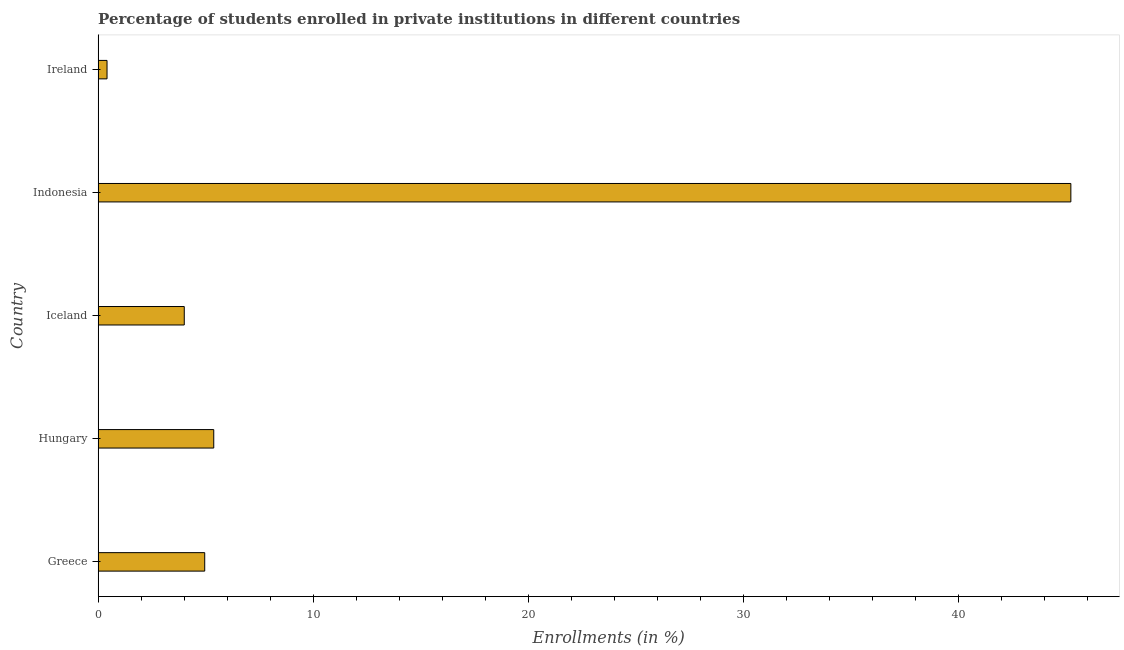Does the graph contain any zero values?
Your answer should be very brief. No. What is the title of the graph?
Provide a short and direct response. Percentage of students enrolled in private institutions in different countries. What is the label or title of the X-axis?
Your answer should be compact. Enrollments (in %). What is the label or title of the Y-axis?
Provide a short and direct response. Country. What is the enrollments in private institutions in Indonesia?
Ensure brevity in your answer.  45.2. Across all countries, what is the maximum enrollments in private institutions?
Give a very brief answer. 45.2. Across all countries, what is the minimum enrollments in private institutions?
Your response must be concise. 0.41. In which country was the enrollments in private institutions minimum?
Your response must be concise. Ireland. What is the sum of the enrollments in private institutions?
Give a very brief answer. 59.95. What is the difference between the enrollments in private institutions in Hungary and Iceland?
Your response must be concise. 1.37. What is the average enrollments in private institutions per country?
Keep it short and to the point. 11.99. What is the median enrollments in private institutions?
Keep it short and to the point. 4.95. In how many countries, is the enrollments in private institutions greater than 40 %?
Give a very brief answer. 1. What is the ratio of the enrollments in private institutions in Indonesia to that in Ireland?
Ensure brevity in your answer.  109.08. What is the difference between the highest and the second highest enrollments in private institutions?
Provide a succinct answer. 39.83. What is the difference between the highest and the lowest enrollments in private institutions?
Provide a short and direct response. 44.79. Are all the bars in the graph horizontal?
Your response must be concise. Yes. How many countries are there in the graph?
Provide a succinct answer. 5. What is the Enrollments (in %) in Greece?
Keep it short and to the point. 4.95. What is the Enrollments (in %) in Hungary?
Offer a very short reply. 5.37. What is the Enrollments (in %) in Iceland?
Offer a terse response. 4. What is the Enrollments (in %) in Indonesia?
Make the answer very short. 45.2. What is the Enrollments (in %) of Ireland?
Provide a short and direct response. 0.41. What is the difference between the Enrollments (in %) in Greece and Hungary?
Give a very brief answer. -0.42. What is the difference between the Enrollments (in %) in Greece and Iceland?
Give a very brief answer. 0.95. What is the difference between the Enrollments (in %) in Greece and Indonesia?
Offer a very short reply. -40.25. What is the difference between the Enrollments (in %) in Greece and Ireland?
Your answer should be compact. 4.54. What is the difference between the Enrollments (in %) in Hungary and Iceland?
Offer a terse response. 1.37. What is the difference between the Enrollments (in %) in Hungary and Indonesia?
Your answer should be very brief. -39.83. What is the difference between the Enrollments (in %) in Hungary and Ireland?
Provide a short and direct response. 4.96. What is the difference between the Enrollments (in %) in Iceland and Indonesia?
Your response must be concise. -41.2. What is the difference between the Enrollments (in %) in Iceland and Ireland?
Your answer should be very brief. 3.59. What is the difference between the Enrollments (in %) in Indonesia and Ireland?
Offer a very short reply. 44.79. What is the ratio of the Enrollments (in %) in Greece to that in Hungary?
Give a very brief answer. 0.92. What is the ratio of the Enrollments (in %) in Greece to that in Iceland?
Provide a short and direct response. 1.24. What is the ratio of the Enrollments (in %) in Greece to that in Indonesia?
Keep it short and to the point. 0.11. What is the ratio of the Enrollments (in %) in Greece to that in Ireland?
Offer a very short reply. 11.95. What is the ratio of the Enrollments (in %) in Hungary to that in Iceland?
Make the answer very short. 1.34. What is the ratio of the Enrollments (in %) in Hungary to that in Indonesia?
Keep it short and to the point. 0.12. What is the ratio of the Enrollments (in %) in Hungary to that in Ireland?
Provide a succinct answer. 12.97. What is the ratio of the Enrollments (in %) in Iceland to that in Indonesia?
Offer a terse response. 0.09. What is the ratio of the Enrollments (in %) in Iceland to that in Ireland?
Provide a short and direct response. 9.66. What is the ratio of the Enrollments (in %) in Indonesia to that in Ireland?
Your answer should be compact. 109.08. 